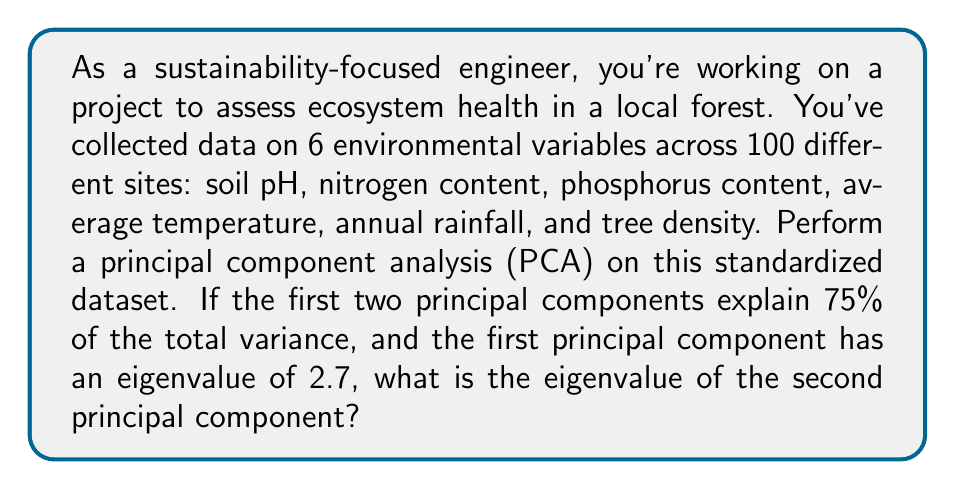Could you help me with this problem? Let's approach this step-by-step:

1) In PCA, the total variance is equal to the number of variables when working with standardized data. Here, we have 6 variables, so the total variance is 6.

2) The eigenvalues represent the amount of variance explained by each principal component. The sum of all eigenvalues equals the total variance.

3) We're told that the first two principal components explain 75% of the total variance. This can be expressed as:

   $$(λ_1 + λ_2) / 6 = 0.75$$

   where $λ_1$ and $λ_2$ are the eigenvalues of the first and second principal components respectively.

4) We're given that $λ_1 = 2.7$. Let's substitute this into our equation:

   $$(2.7 + λ_2) / 6 = 0.75$$

5) Now we can solve for $λ_2$:

   $$2.7 + λ_2 = 0.75 * 6 = 4.5$$
   $$λ_2 = 4.5 - 2.7 = 1.8$$

Therefore, the eigenvalue of the second principal component is 1.8.
Answer: 1.8 